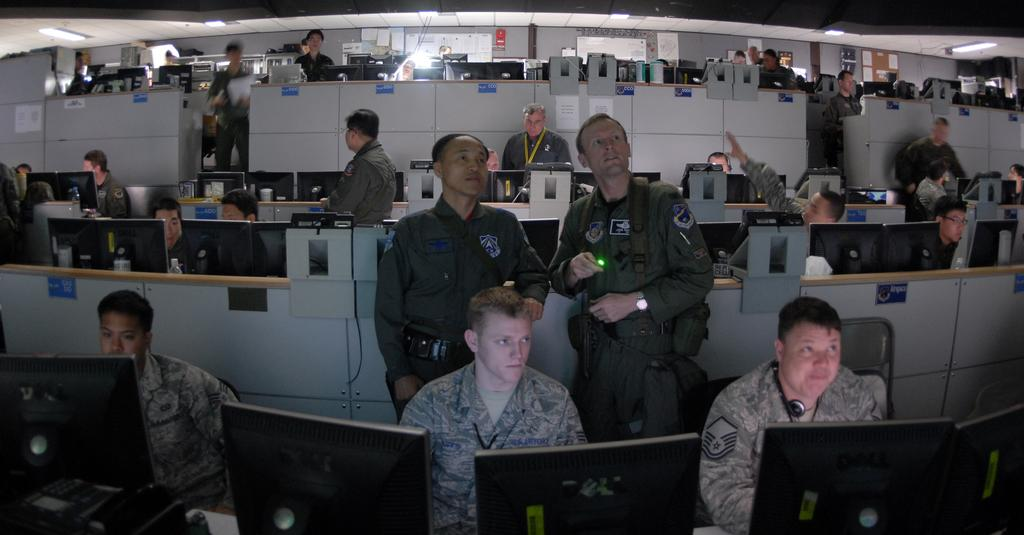What are the men in the image doing? The men in the image are sitting and standing. Where are the men located in relation to the table? The men are sitting in front of the table. What objects are on the table? There are computers on the table. What type of environment is depicted in the image? The setting appears to be in an office. What type of hammer is being used by the men in the image? There is no hammer present in the image; the men are sitting and standing near computers on a table. 